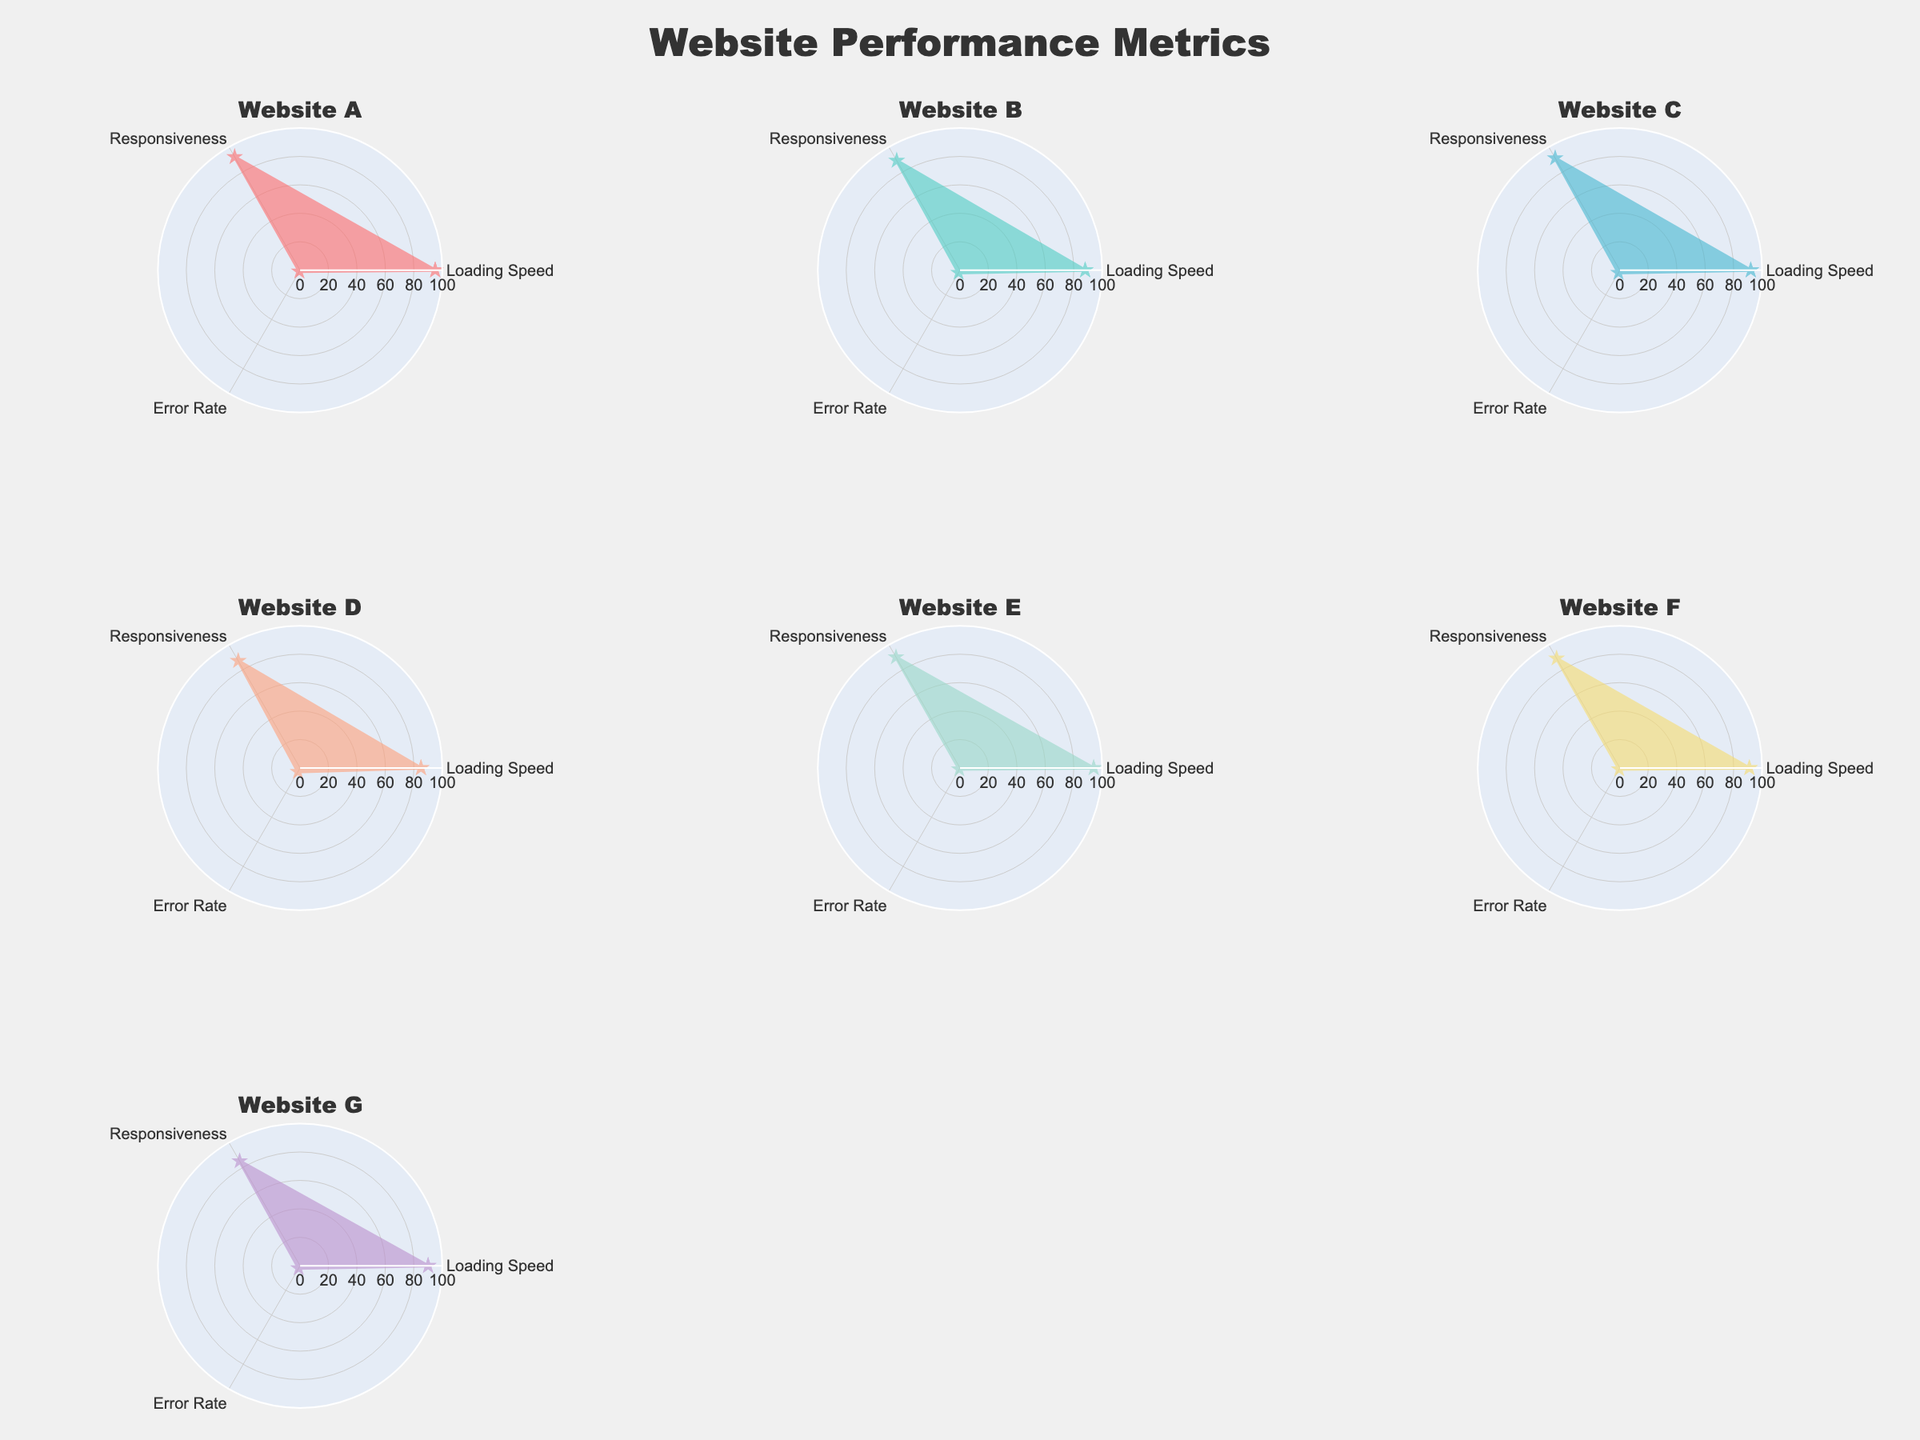What is the title of the figure? The figure's title is clearly positioned at the top center of the chart, denoted in a very large font.
Answer: "Website Performance Metrics" Which website has the highest loading speed? By observing the radar charts, Website A has the highest loading speed value of 95.
Answer: Website A How does the error rate of Website G compare to Website A? Website G has an error rate of 2 while Website A has an error rate of 1, making Website G's error rate higher.
Answer: Website G has a higher error rate What is the average responsiveness of all websites? Summing the responsiveness values: 92 (A) + 89 (B) + 91 (C) + 87 (D) + 90 (E) + 89 (F) + 85 (G) = 623. Then divide by 7 (the number of websites).
Answer: 89 Which website has the lowest error rate? Both Website A, Website E, and Website F have an error rate of 1, making them the websites with the lowest error rate.
Answer: Website A, Website E, and Website F Among all websites, which two have the most similar radar chart pattern? The radar charts for Website C and Website F have visually similar shapes and values across all three performance metrics.
Answer: Website C and Website F Which website has the lowest performance for responsiveness? Among all radar charts, Website G has the lowest value of responsiveness with a score of 85.
Answer: Website G What is the difference in loading speed between Website A and Website D? Website A has a loading speed of 95 while Website D has a loading speed of 85. 95 - 85 = 10.
Answer: 10 Rank all websites by their average performance across all metrics from highest to lowest. Calculate average performance: Website A (62), Website B (59.67), Website C (61.67), Website D (58.33), Website E (61.67), Website F (60.33), Website G (59). Rank: A, C/E, F, B, G, D.
Answer: A, C/E, F, B, G, D Which website has the most balanced performance across all metrics? By observing the radar charts, Website C has all metrics at similar, high values making it the most balanced.
Answer: Website C 